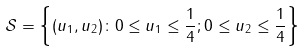<formula> <loc_0><loc_0><loc_500><loc_500>\mathcal { S } & = \left \{ ( u _ { 1 } , u _ { 2 } ) \colon 0 \leq u _ { 1 } \leq \frac { 1 } { 4 } ; 0 \leq u _ { 2 } \leq \frac { 1 } { 4 } \right \}</formula> 